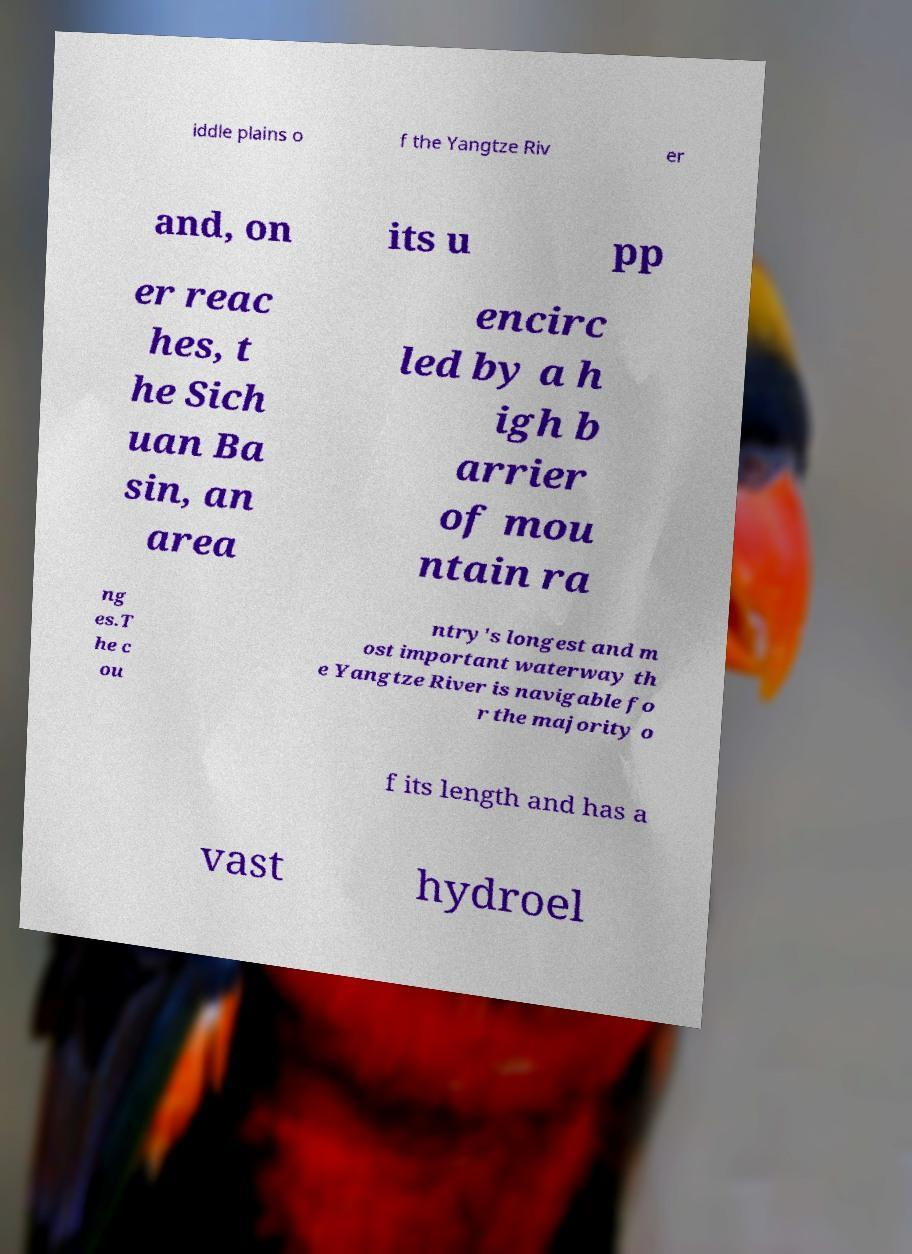I need the written content from this picture converted into text. Can you do that? iddle plains o f the Yangtze Riv er and, on its u pp er reac hes, t he Sich uan Ba sin, an area encirc led by a h igh b arrier of mou ntain ra ng es.T he c ou ntry's longest and m ost important waterway th e Yangtze River is navigable fo r the majority o f its length and has a vast hydroel 